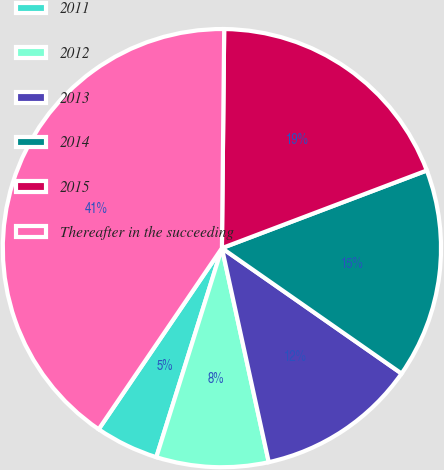Convert chart. <chart><loc_0><loc_0><loc_500><loc_500><pie_chart><fcel>2011<fcel>2012<fcel>2013<fcel>2014<fcel>2015<fcel>Thereafter in the succeeding<nl><fcel>4.67%<fcel>8.27%<fcel>11.87%<fcel>15.47%<fcel>19.07%<fcel>40.66%<nl></chart> 